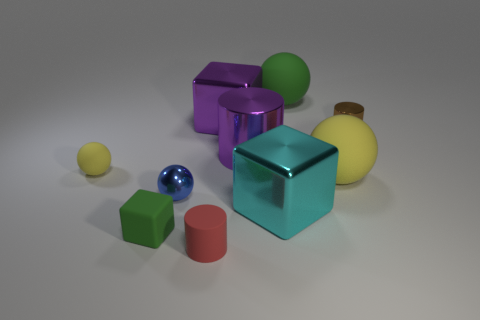Can you describe the lighting and shadows in the scene? The scene is softly lit from the upper left, casting gentle shadows to the right of the objects. The shadows are soft-edged, suggesting diffuse lighting, which contributes to the calm and balanced atmosphere of the image. 